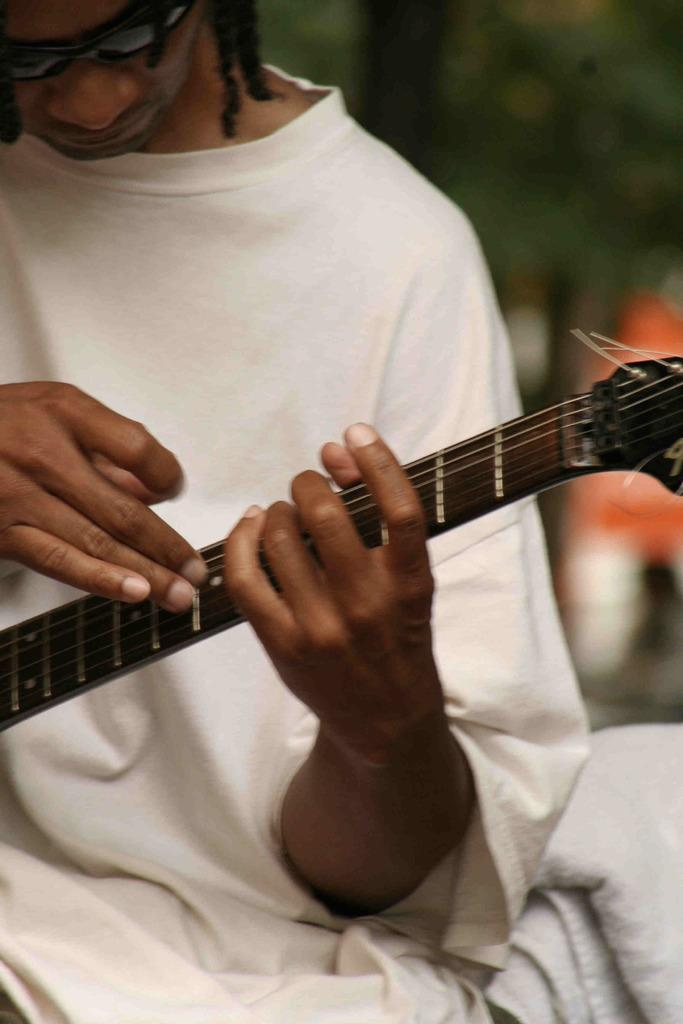What is the main subject of the image? The main subject of the image is a man. What is the man holding in his hands? The man is holding a guitar in his hands. How many scarves is the man wearing in the image? There is no mention of a scarf in the image, so it cannot be determined how many scarves the man is wearing. 